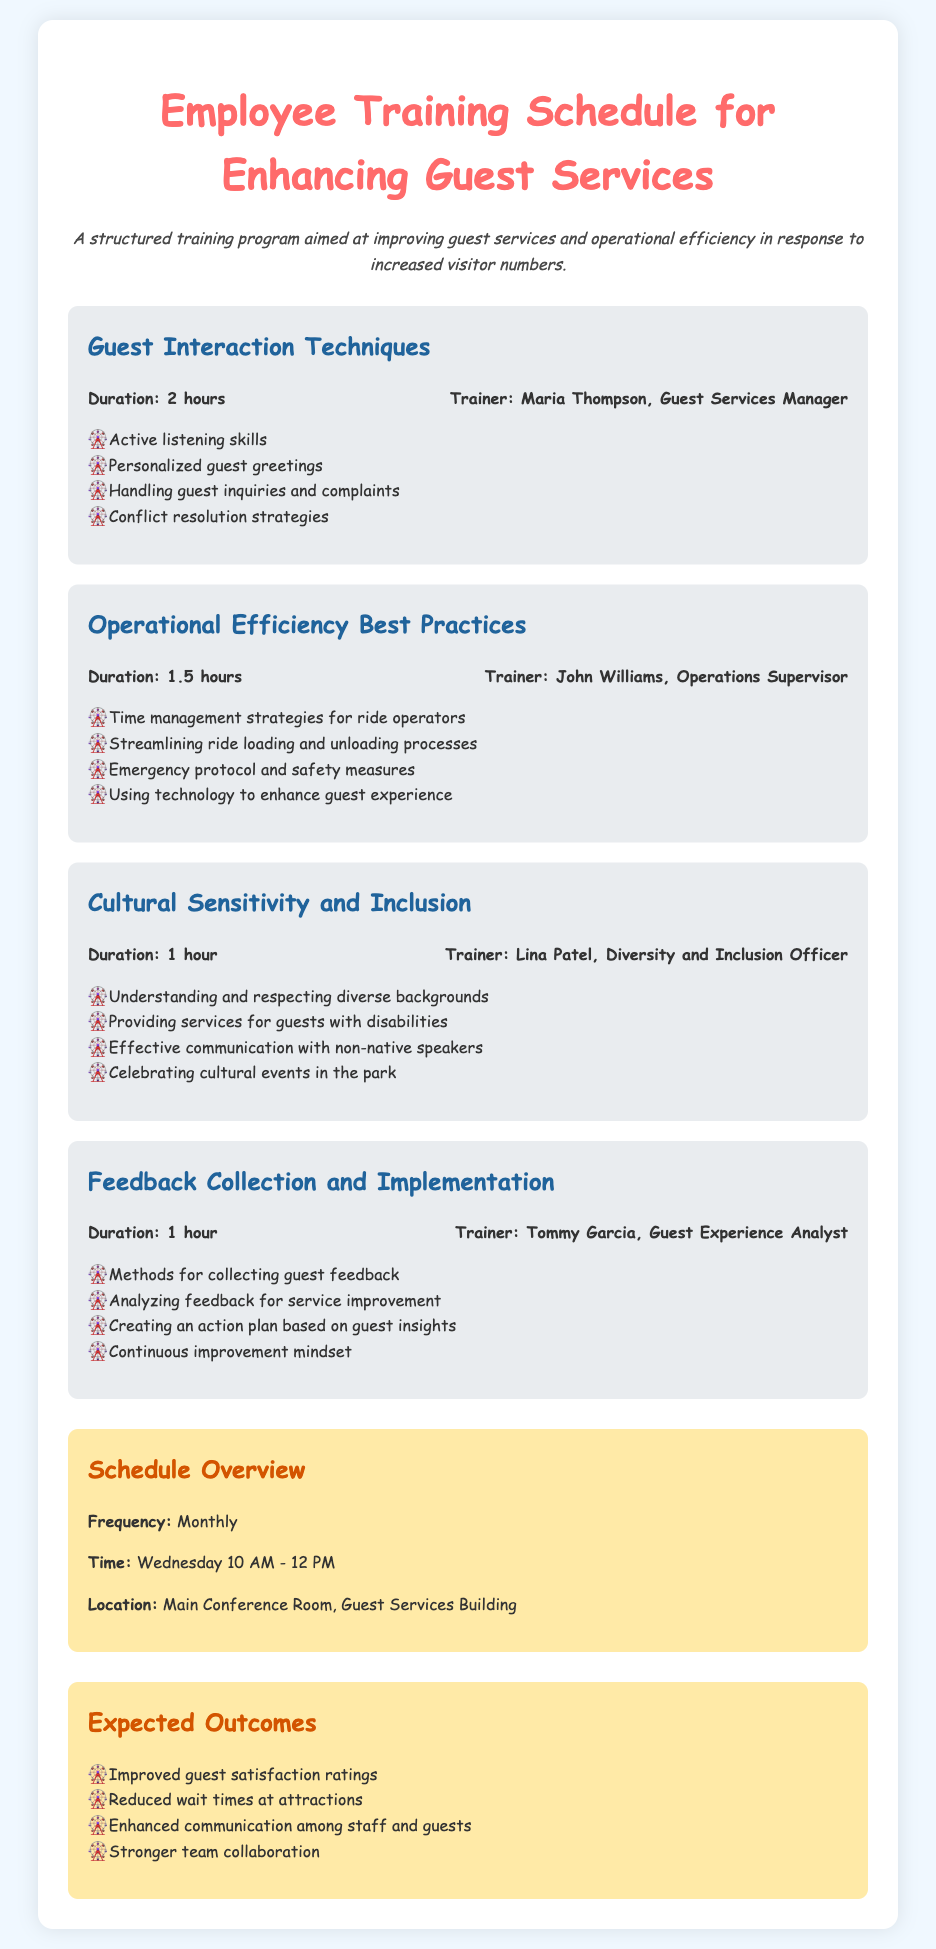What is the duration of the "Guest Interaction Techniques" module? The duration is explicitly stated in the document.
Answer: 2 hours Who is the trainer for the "Operational Efficiency Best Practices" module? The trainer's name is provided alongside the module details.
Answer: John Williams How often is the training scheduled? The frequency of the training sessions is detailed in the schedule overview section.
Answer: Monthly What is one of the expected outcomes of the training? The outcomes are listed under the "Expected Outcomes" section.
Answer: Improved guest satisfaction ratings What is the location of the training sessions? The location is specified in the schedule overview section.
Answer: Main Conference Room, Guest Services Building How long is the "Cultural Sensitivity and Inclusion" module? The duration is mentioned in the module's header section.
Answer: 1 hour Which trainer focuses on feedback collection? The name associated with this module is found in the module details.
Answer: Tommy Garcia What color is the background of the document? The background color is described in the style section of the document.
Answer: Light blue (or #f0f8ff) 